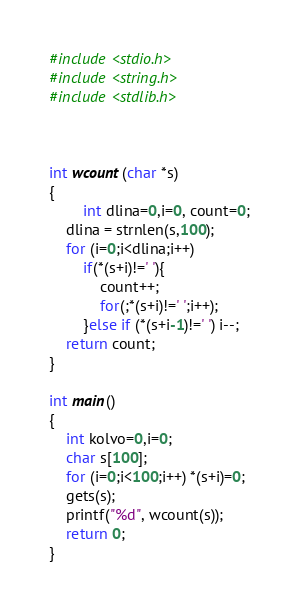<code> <loc_0><loc_0><loc_500><loc_500><_C_>#include <stdio.h>
#include <string.h>
#include <stdlib.h>



int wcount(char *s) 
{
        int dlina=0,i=0, count=0;
	dlina = strnlen(s,100);
	for (i=0;i<dlina;i++)
		if(*(s+i)!=' '){
			count++;
			for(;*(s+i)!=' ';i++);
		}else if (*(s+i-1)!=' ') i--;
	return count;
}

int main()
{	
	int kolvo=0,i=0;
	char s[100];
	for (i=0;i<100;i++) *(s+i)=0;
	gets(s);
	printf("%d", wcount(s));
	return 0;
}</code> 